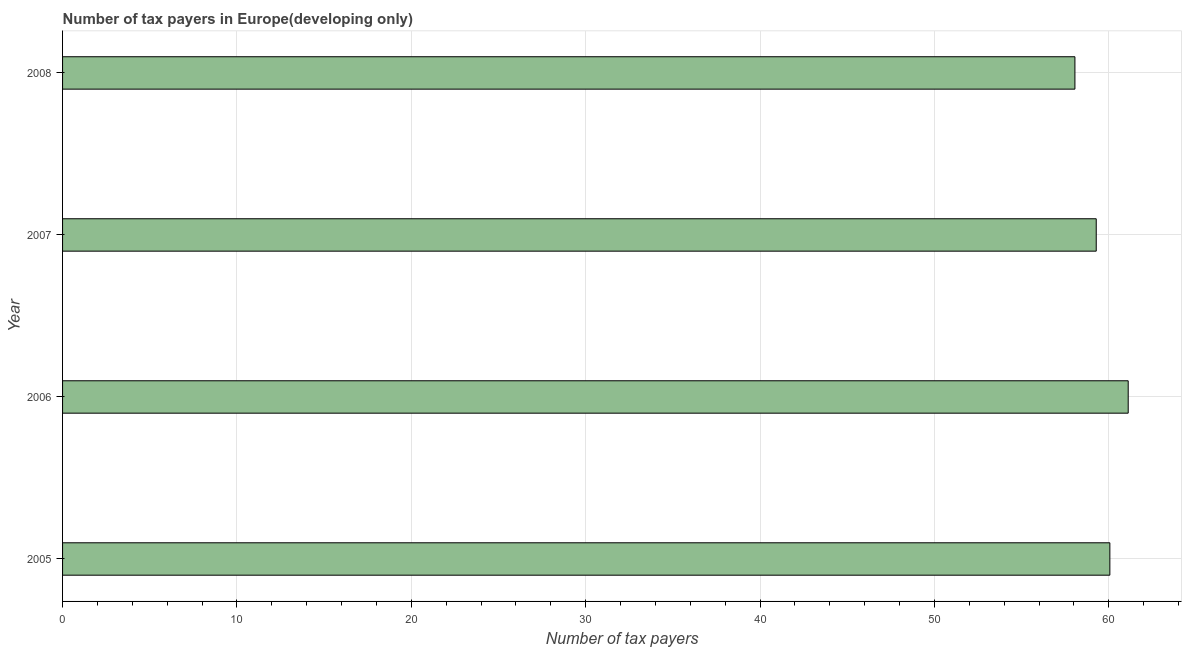What is the title of the graph?
Give a very brief answer. Number of tax payers in Europe(developing only). What is the label or title of the X-axis?
Provide a short and direct response. Number of tax payers. What is the number of tax payers in 2006?
Provide a succinct answer. 61.11. Across all years, what is the maximum number of tax payers?
Your answer should be compact. 61.11. Across all years, what is the minimum number of tax payers?
Offer a very short reply. 58.06. In which year was the number of tax payers maximum?
Ensure brevity in your answer.  2006. What is the sum of the number of tax payers?
Make the answer very short. 238.5. What is the difference between the number of tax payers in 2006 and 2008?
Keep it short and to the point. 3.06. What is the average number of tax payers per year?
Keep it short and to the point. 59.63. What is the median number of tax payers?
Offer a terse response. 59.67. In how many years, is the number of tax payers greater than 36 ?
Offer a very short reply. 4. Do a majority of the years between 2008 and 2006 (inclusive) have number of tax payers greater than 14 ?
Give a very brief answer. Yes. What is the ratio of the number of tax payers in 2006 to that in 2007?
Give a very brief answer. 1.03. Is the number of tax payers in 2005 less than that in 2008?
Your answer should be very brief. No. What is the difference between the highest and the second highest number of tax payers?
Ensure brevity in your answer.  1.05. Is the sum of the number of tax payers in 2005 and 2007 greater than the maximum number of tax payers across all years?
Your answer should be very brief. Yes. What is the difference between the highest and the lowest number of tax payers?
Provide a succinct answer. 3.06. In how many years, is the number of tax payers greater than the average number of tax payers taken over all years?
Make the answer very short. 2. Are all the bars in the graph horizontal?
Your answer should be compact. Yes. How many years are there in the graph?
Give a very brief answer. 4. What is the difference between two consecutive major ticks on the X-axis?
Provide a short and direct response. 10. What is the Number of tax payers of 2005?
Your answer should be very brief. 60.06. What is the Number of tax payers of 2006?
Offer a terse response. 61.11. What is the Number of tax payers of 2007?
Give a very brief answer. 59.28. What is the Number of tax payers in 2008?
Your answer should be very brief. 58.06. What is the difference between the Number of tax payers in 2005 and 2006?
Keep it short and to the point. -1.05. What is the difference between the Number of tax payers in 2005 and 2007?
Ensure brevity in your answer.  0.78. What is the difference between the Number of tax payers in 2005 and 2008?
Ensure brevity in your answer.  2. What is the difference between the Number of tax payers in 2006 and 2007?
Offer a terse response. 1.83. What is the difference between the Number of tax payers in 2006 and 2008?
Provide a succinct answer. 3.06. What is the difference between the Number of tax payers in 2007 and 2008?
Provide a succinct answer. 1.22. What is the ratio of the Number of tax payers in 2005 to that in 2007?
Ensure brevity in your answer.  1.01. What is the ratio of the Number of tax payers in 2005 to that in 2008?
Your answer should be compact. 1.03. What is the ratio of the Number of tax payers in 2006 to that in 2007?
Keep it short and to the point. 1.03. What is the ratio of the Number of tax payers in 2006 to that in 2008?
Offer a very short reply. 1.05. What is the ratio of the Number of tax payers in 2007 to that in 2008?
Your answer should be very brief. 1.02. 